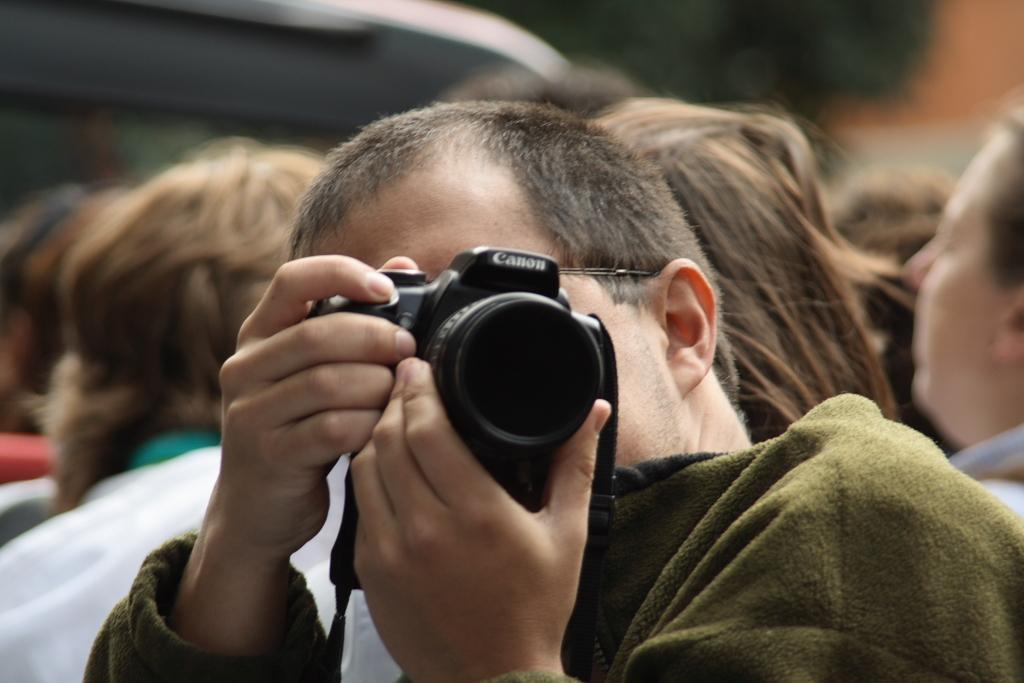Who is the main subject in the image? There is a man in the image. What is the man holding in his hands? The man is holding a camera in his hands. Can you describe the background of the image? There are persons visible in the background of the image. What type of horn can be heard in the image? There is no horn present in the image, and therefore no sound can be heard. 